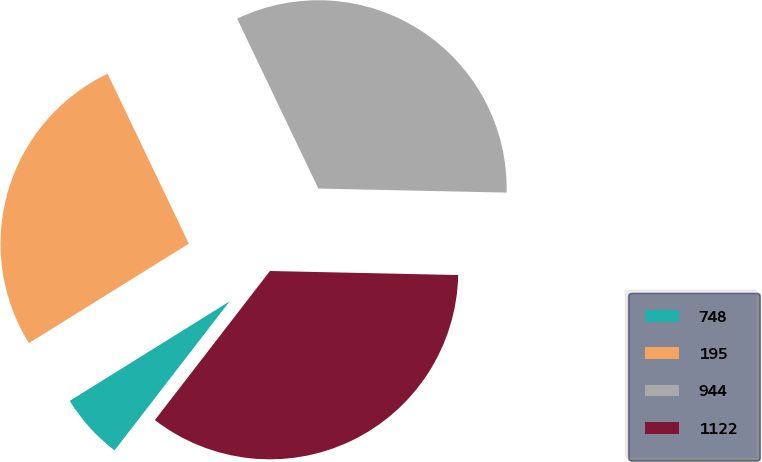Convert chart. <chart><loc_0><loc_0><loc_500><loc_500><pie_chart><fcel>748<fcel>195<fcel>944<fcel>1122<nl><fcel>5.68%<fcel>26.76%<fcel>32.44%<fcel>35.12%<nl></chart> 